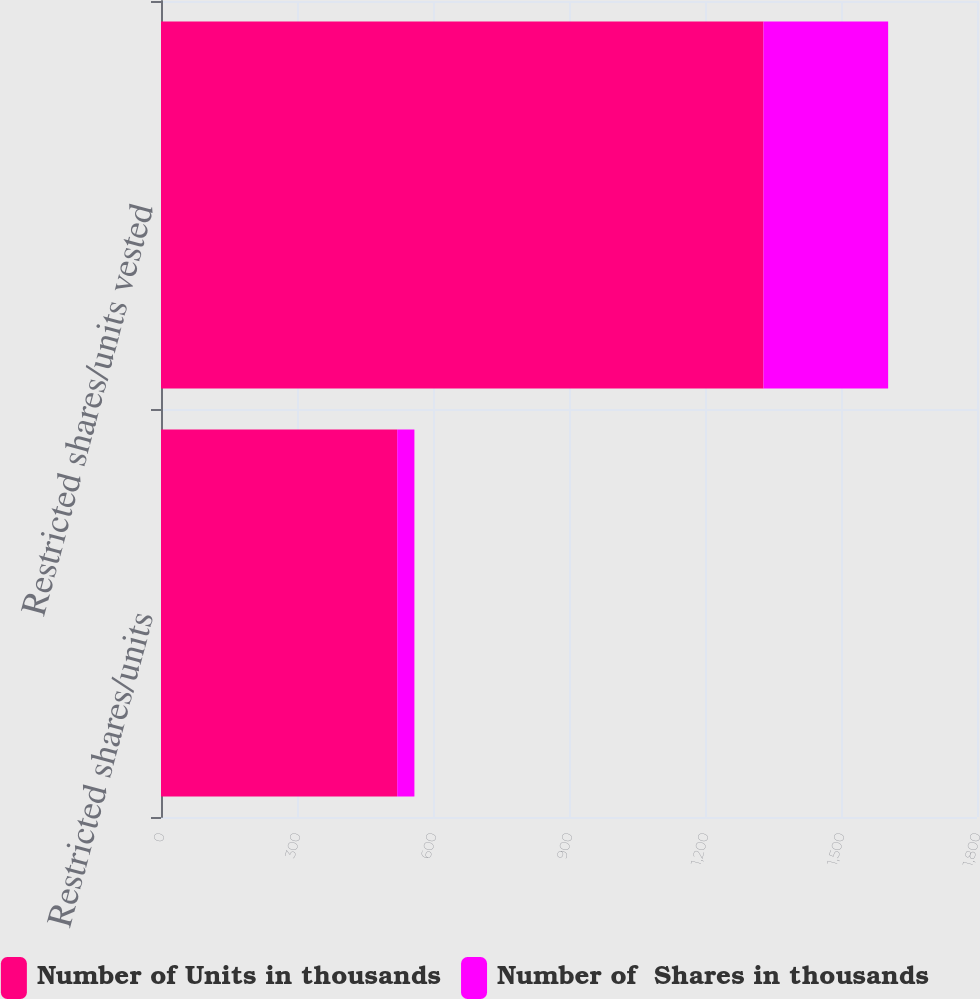<chart> <loc_0><loc_0><loc_500><loc_500><stacked_bar_chart><ecel><fcel>Restricted shares/units<fcel>Restricted shares/units vested<nl><fcel>Number of Units in thousands<fcel>521<fcel>1329<nl><fcel>Number of  Shares in thousands<fcel>38<fcel>275<nl></chart> 